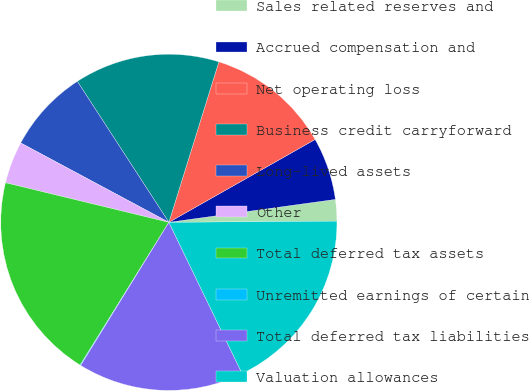<chart> <loc_0><loc_0><loc_500><loc_500><pie_chart><fcel>Sales related reserves and<fcel>Accrued compensation and<fcel>Net operating loss<fcel>Business credit carryforward<fcel>Long-lived assets<fcel>Other<fcel>Total deferred tax assets<fcel>Unremitted earnings of certain<fcel>Total deferred tax liabilities<fcel>Valuation allowances<nl><fcel>2.06%<fcel>6.03%<fcel>11.99%<fcel>13.97%<fcel>8.01%<fcel>4.04%<fcel>19.93%<fcel>0.07%<fcel>15.96%<fcel>17.94%<nl></chart> 